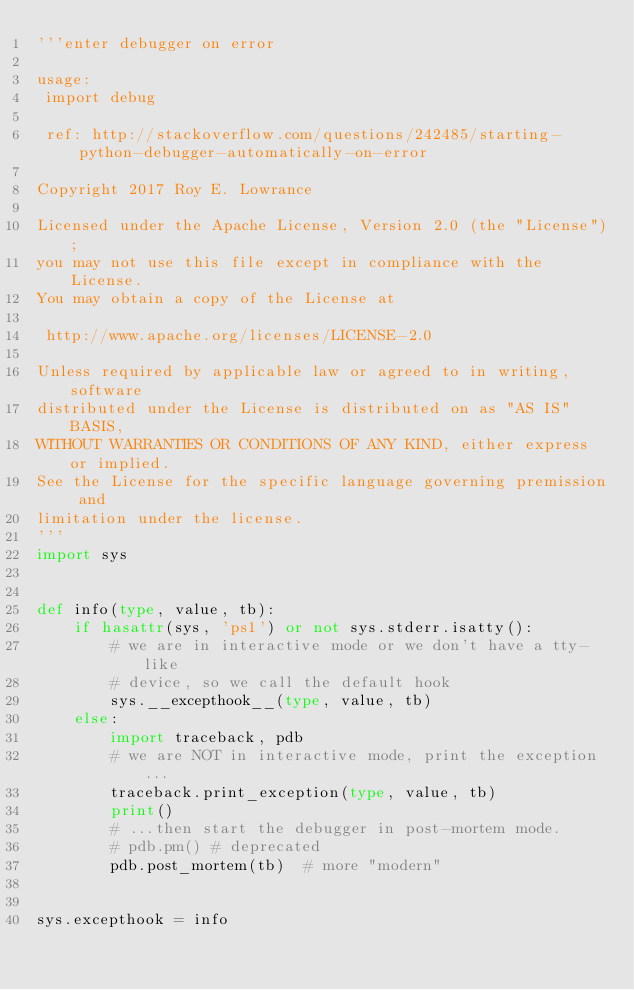Convert code to text. <code><loc_0><loc_0><loc_500><loc_500><_Python_>'''enter debugger on error

usage:
 import debug

 ref: http://stackoverflow.com/questions/242485/starting-python-debugger-automatically-on-error

Copyright 2017 Roy E. Lowrance

Licensed under the Apache License, Version 2.0 (the "License");
you may not use this file except in compliance with the License.
You may obtain a copy of the License at

 http://www.apache.org/licenses/LICENSE-2.0

Unless required by applicable law or agreed to in writing, software
distributed under the License is distributed on as "AS IS" BASIS,
WITHOUT WARRANTIES OR CONDITIONS OF ANY KIND, either express or implied.
See the License for the specific language governing premission and
limitation under the license.
'''
import sys


def info(type, value, tb):
    if hasattr(sys, 'ps1') or not sys.stderr.isatty():
        # we are in interactive mode or we don't have a tty-like
        # device, so we call the default hook
        sys.__excepthook__(type, value, tb)
    else:
        import traceback, pdb
        # we are NOT in interactive mode, print the exception...
        traceback.print_exception(type, value, tb)
        print()
        # ...then start the debugger in post-mortem mode.
        # pdb.pm() # deprecated
        pdb.post_mortem(tb)  # more "modern"


sys.excepthook = info</code> 